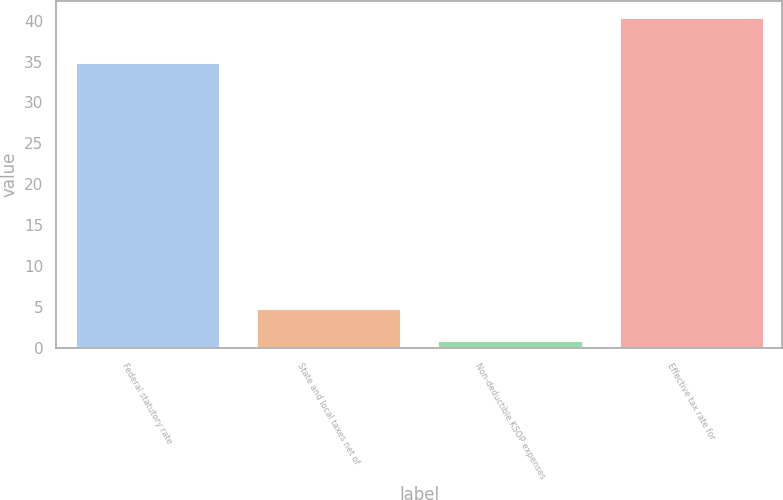Convert chart. <chart><loc_0><loc_0><loc_500><loc_500><bar_chart><fcel>Federal statutory rate<fcel>State and local taxes net of<fcel>Non-deductible KSOP expenses<fcel>Effective tax rate for<nl><fcel>35<fcel>4.94<fcel>1<fcel>40.4<nl></chart> 